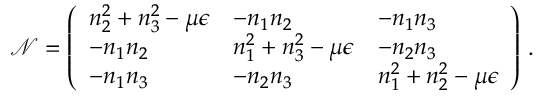<formula> <loc_0><loc_0><loc_500><loc_500>\mathcal { N } = \left ( \begin{array} { l l l } { n _ { 2 } ^ { 2 } + n _ { 3 } ^ { 2 } - \mu \epsilon } & { - n _ { 1 } n _ { 2 } } & { - n _ { 1 } n _ { 3 } } \\ { - n _ { 1 } n _ { 2 } } & { n _ { 1 } ^ { 2 } + n _ { 3 } ^ { 2 } - \mu \epsilon } & { - n _ { 2 } n _ { 3 } } \\ { - n _ { 1 } n _ { 3 } } & { - n _ { 2 } n _ { 3 } } & { n _ { 1 } ^ { 2 } + n _ { 2 } ^ { 2 } - \mu \epsilon } \end{array} \right ) \, .</formula> 